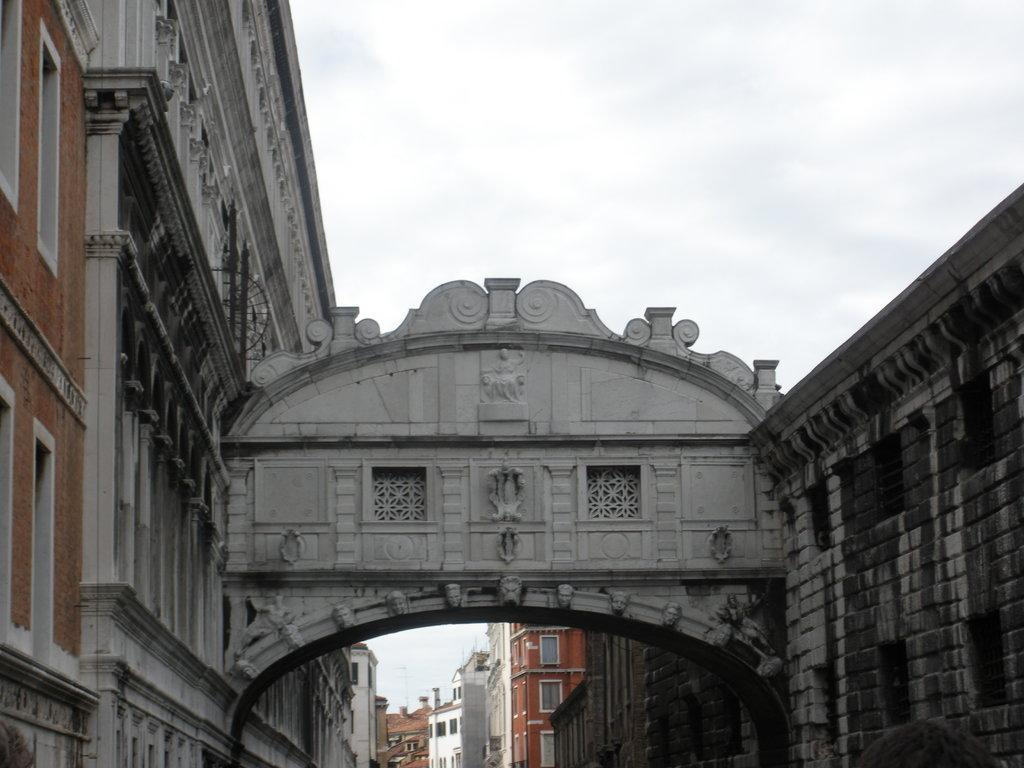What type of structures can be seen in the image? There are buildings in the image. What feature is present on one of the buildings? There is a window in the image. What part of the natural environment is visible in the image? The sky is visible in the image. What type of pet can be seen sitting on the windowsill in the image? There is no pet visible in the image, as it only features buildings and a window. What type of music is being played by the band in the image? There is no band present in the image; it only features buildings, a window, and the sky. 